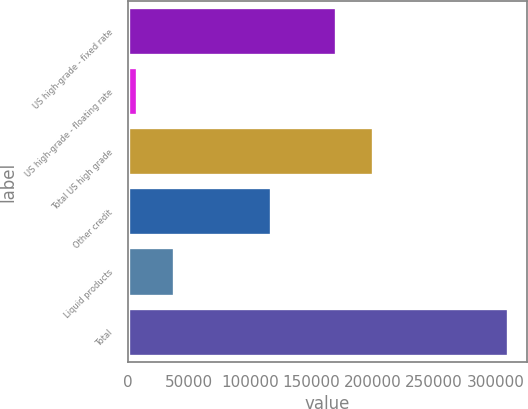Convert chart. <chart><loc_0><loc_0><loc_500><loc_500><bar_chart><fcel>US high-grade - fixed rate<fcel>US high-grade - floating rate<fcel>Total US high grade<fcel>Other credit<fcel>Liquid products<fcel>Total<nl><fcel>170219<fcel>7507<fcel>200470<fcel>116974<fcel>37758.4<fcel>310021<nl></chart> 